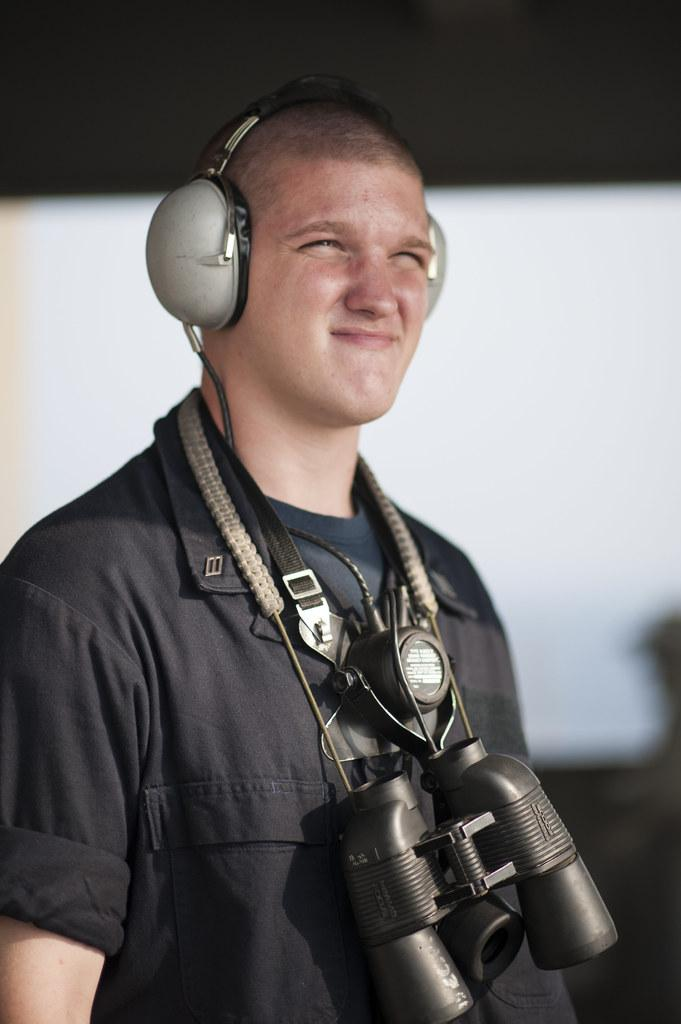What can be seen in the image? There is a person in the image. What is the person wearing in the image? The person is wearing binoculars and a headset. Can you describe the background of the image? The background of the image is blurry. Are there any squirrels visible in the image? There are no squirrels present in the image. 